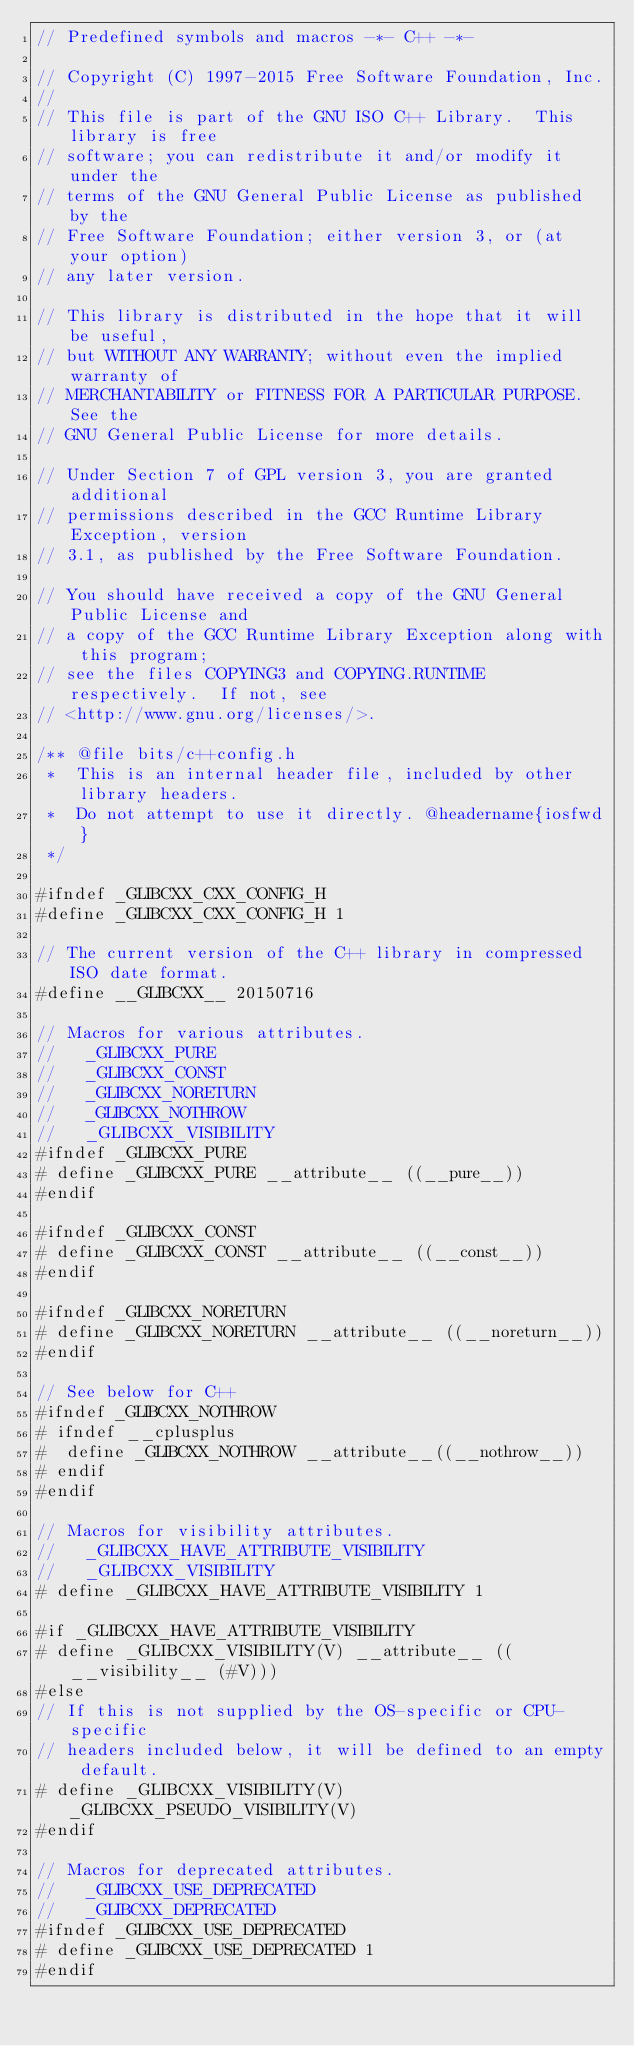Convert code to text. <code><loc_0><loc_0><loc_500><loc_500><_C_>// Predefined symbols and macros -*- C++ -*-

// Copyright (C) 1997-2015 Free Software Foundation, Inc.
//
// This file is part of the GNU ISO C++ Library.  This library is free
// software; you can redistribute it and/or modify it under the
// terms of the GNU General Public License as published by the
// Free Software Foundation; either version 3, or (at your option)
// any later version.

// This library is distributed in the hope that it will be useful,
// but WITHOUT ANY WARRANTY; without even the implied warranty of
// MERCHANTABILITY or FITNESS FOR A PARTICULAR PURPOSE.  See the
// GNU General Public License for more details.

// Under Section 7 of GPL version 3, you are granted additional
// permissions described in the GCC Runtime Library Exception, version
// 3.1, as published by the Free Software Foundation.

// You should have received a copy of the GNU General Public License and
// a copy of the GCC Runtime Library Exception along with this program;
// see the files COPYING3 and COPYING.RUNTIME respectively.  If not, see
// <http://www.gnu.org/licenses/>.

/** @file bits/c++config.h
 *  This is an internal header file, included by other library headers.
 *  Do not attempt to use it directly. @headername{iosfwd}
 */

#ifndef _GLIBCXX_CXX_CONFIG_H
#define _GLIBCXX_CXX_CONFIG_H 1

// The current version of the C++ library in compressed ISO date format.
#define __GLIBCXX__ 20150716

// Macros for various attributes.
//   _GLIBCXX_PURE
//   _GLIBCXX_CONST
//   _GLIBCXX_NORETURN
//   _GLIBCXX_NOTHROW
//   _GLIBCXX_VISIBILITY
#ifndef _GLIBCXX_PURE
# define _GLIBCXX_PURE __attribute__ ((__pure__))
#endif

#ifndef _GLIBCXX_CONST
# define _GLIBCXX_CONST __attribute__ ((__const__))
#endif

#ifndef _GLIBCXX_NORETURN
# define _GLIBCXX_NORETURN __attribute__ ((__noreturn__))
#endif

// See below for C++
#ifndef _GLIBCXX_NOTHROW
# ifndef __cplusplus
#  define _GLIBCXX_NOTHROW __attribute__((__nothrow__))
# endif
#endif

// Macros for visibility attributes.
//   _GLIBCXX_HAVE_ATTRIBUTE_VISIBILITY
//   _GLIBCXX_VISIBILITY
# define _GLIBCXX_HAVE_ATTRIBUTE_VISIBILITY 1

#if _GLIBCXX_HAVE_ATTRIBUTE_VISIBILITY
# define _GLIBCXX_VISIBILITY(V) __attribute__ ((__visibility__ (#V)))
#else
// If this is not supplied by the OS-specific or CPU-specific
// headers included below, it will be defined to an empty default.
# define _GLIBCXX_VISIBILITY(V) _GLIBCXX_PSEUDO_VISIBILITY(V)
#endif

// Macros for deprecated attributes.
//   _GLIBCXX_USE_DEPRECATED
//   _GLIBCXX_DEPRECATED
#ifndef _GLIBCXX_USE_DEPRECATED
# define _GLIBCXX_USE_DEPRECATED 1
#endif
</code> 